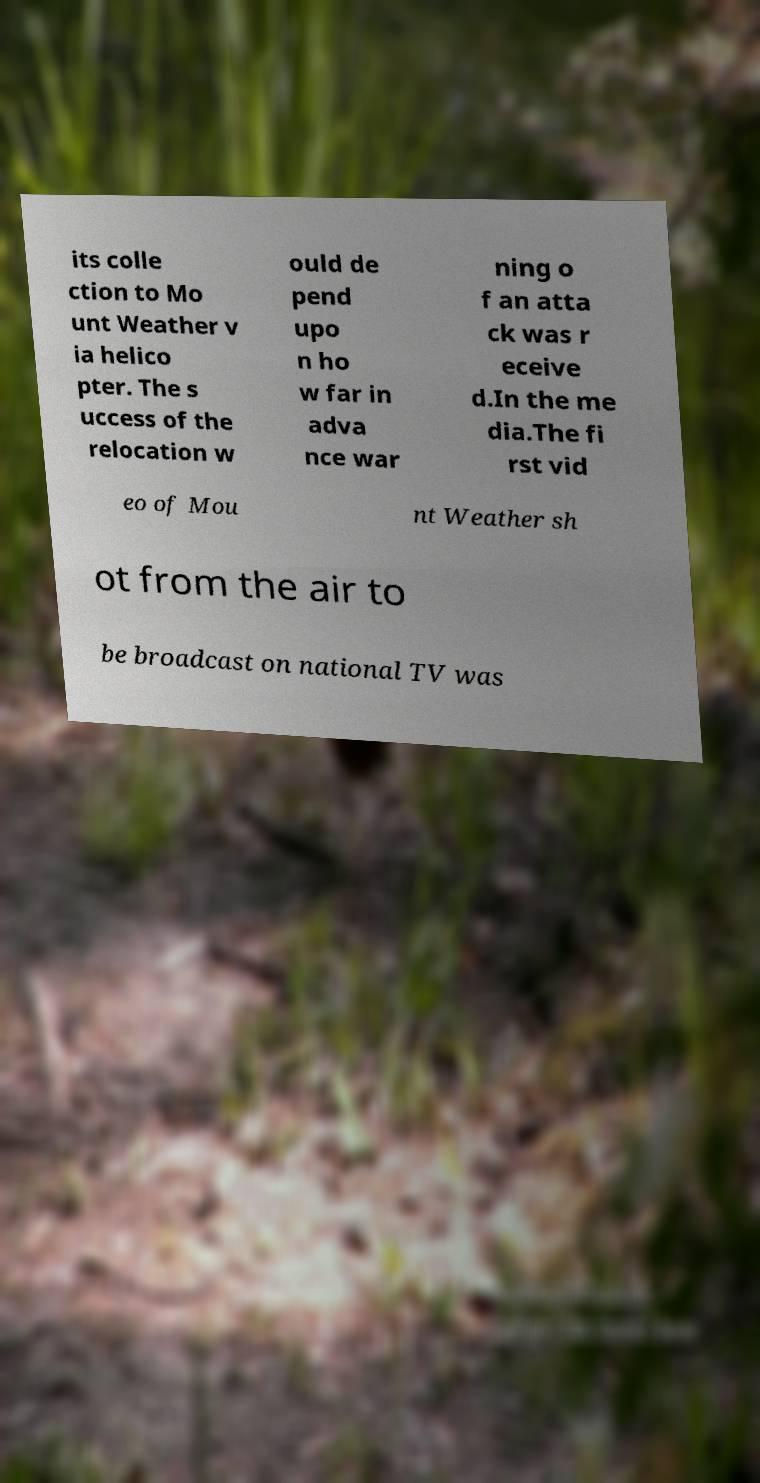There's text embedded in this image that I need extracted. Can you transcribe it verbatim? its colle ction to Mo unt Weather v ia helico pter. The s uccess of the relocation w ould de pend upo n ho w far in adva nce war ning o f an atta ck was r eceive d.In the me dia.The fi rst vid eo of Mou nt Weather sh ot from the air to be broadcast on national TV was 